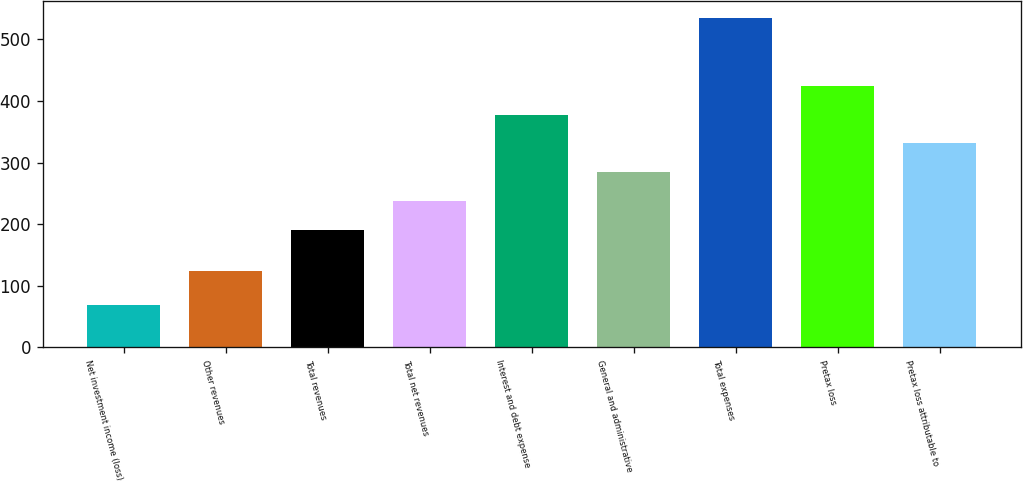Convert chart. <chart><loc_0><loc_0><loc_500><loc_500><bar_chart><fcel>Net investment income (loss)<fcel>Other revenues<fcel>Total revenues<fcel>Total net revenues<fcel>Interest and debt expense<fcel>General and administrative<fcel>Total expenses<fcel>Pretax loss<fcel>Pretax loss attributable to<nl><fcel>68<fcel>124<fcel>191<fcel>237.7<fcel>377.8<fcel>284.4<fcel>535<fcel>424.5<fcel>331.1<nl></chart> 